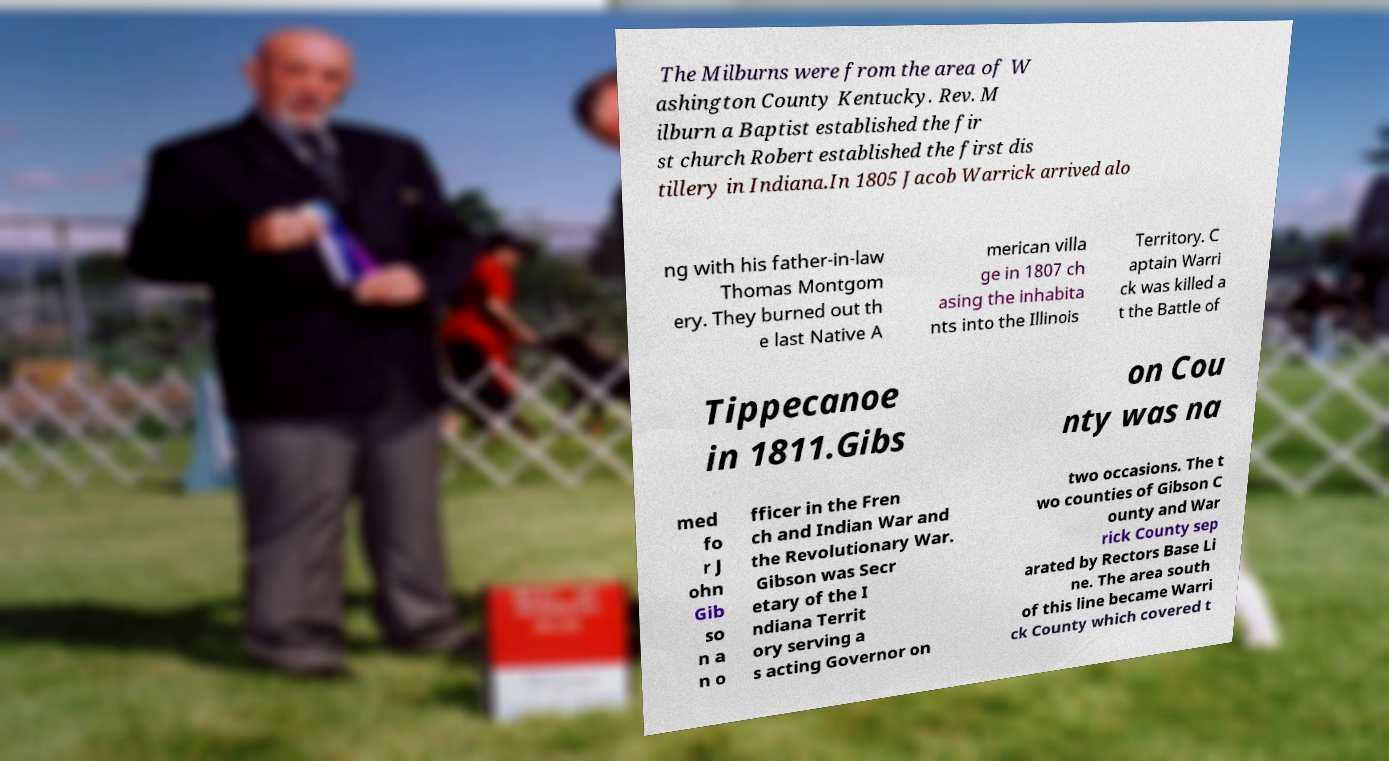Please read and relay the text visible in this image. What does it say? The Milburns were from the area of W ashington County Kentucky. Rev. M ilburn a Baptist established the fir st church Robert established the first dis tillery in Indiana.In 1805 Jacob Warrick arrived alo ng with his father-in-law Thomas Montgom ery. They burned out th e last Native A merican villa ge in 1807 ch asing the inhabita nts into the Illinois Territory. C aptain Warri ck was killed a t the Battle of Tippecanoe in 1811.Gibs on Cou nty was na med fo r J ohn Gib so n a n o fficer in the Fren ch and Indian War and the Revolutionary War. Gibson was Secr etary of the I ndiana Territ ory serving a s acting Governor on two occasions. The t wo counties of Gibson C ounty and War rick County sep arated by Rectors Base Li ne. The area south of this line became Warri ck County which covered t 